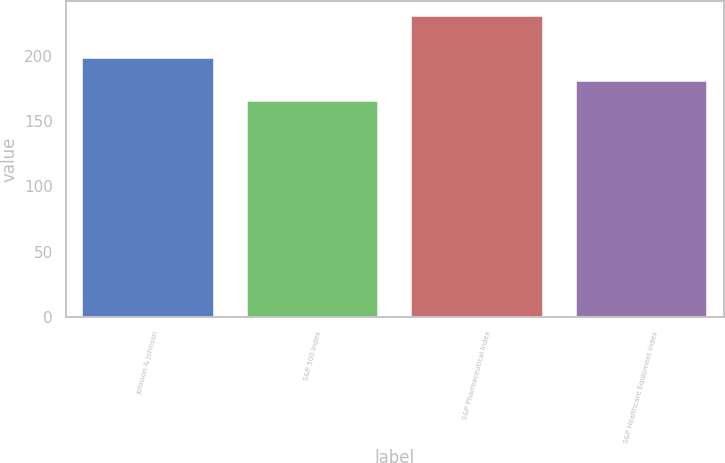Convert chart. <chart><loc_0><loc_0><loc_500><loc_500><bar_chart><fcel>Johnson & Johnson<fcel>S&P 500 Index<fcel>S&P Pharmaceutical Index<fcel>S&P Healthcare Equipment Index<nl><fcel>198.55<fcel>165.6<fcel>230.37<fcel>180.22<nl></chart> 